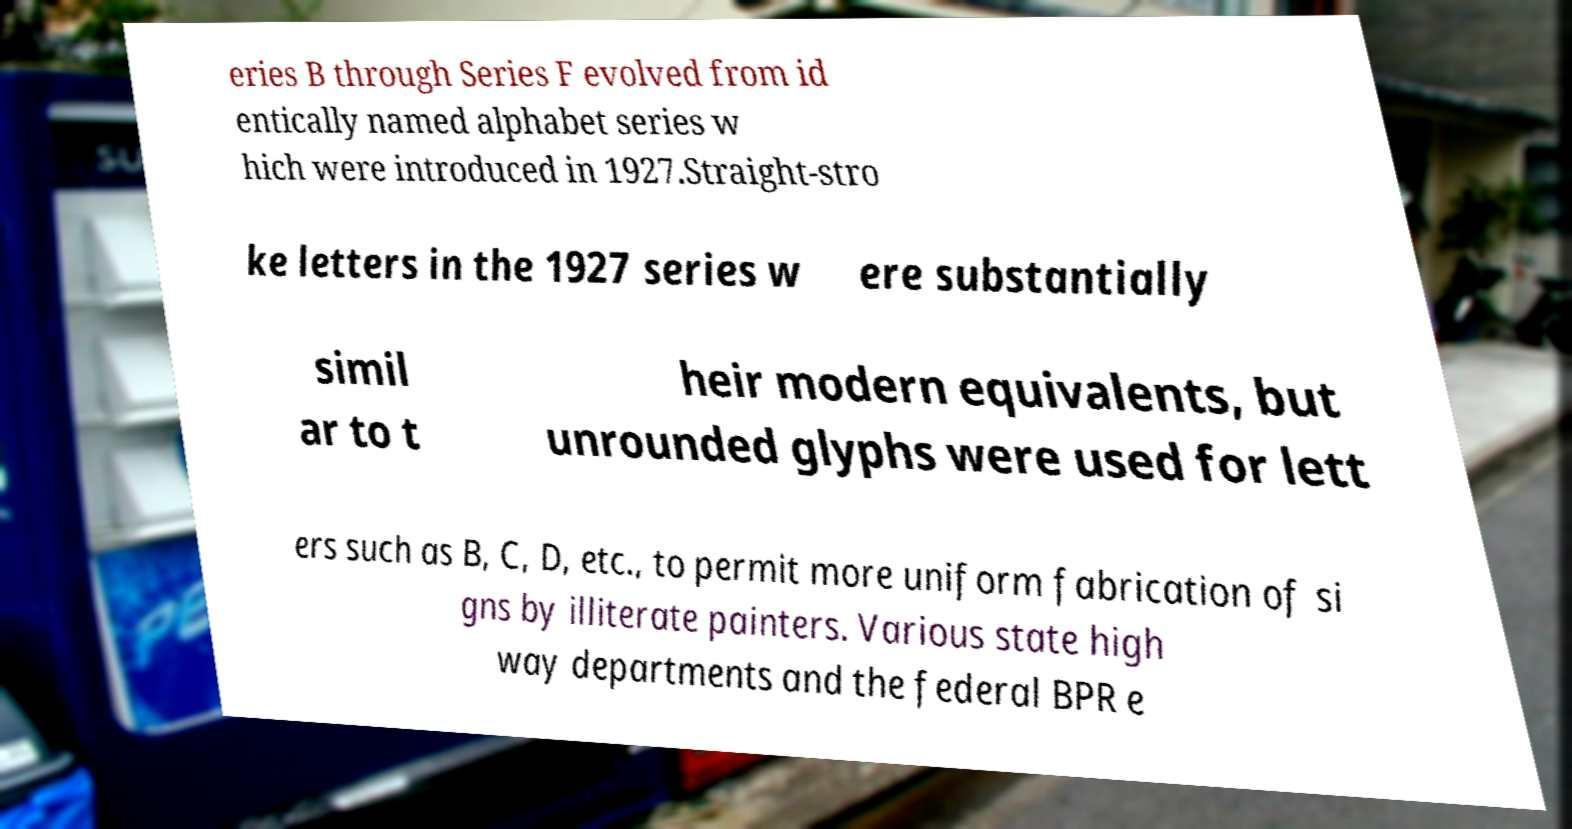For documentation purposes, I need the text within this image transcribed. Could you provide that? eries B through Series F evolved from id entically named alphabet series w hich were introduced in 1927.Straight-stro ke letters in the 1927 series w ere substantially simil ar to t heir modern equivalents, but unrounded glyphs were used for lett ers such as B, C, D, etc., to permit more uniform fabrication of si gns by illiterate painters. Various state high way departments and the federal BPR e 